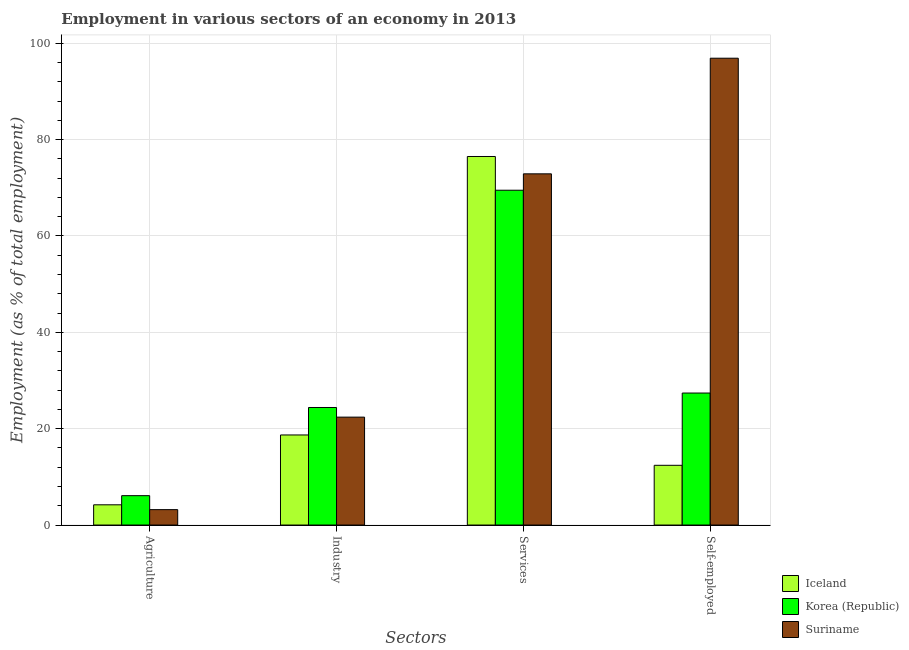How many different coloured bars are there?
Your answer should be compact. 3. Are the number of bars per tick equal to the number of legend labels?
Offer a very short reply. Yes. Are the number of bars on each tick of the X-axis equal?
Offer a terse response. Yes. How many bars are there on the 1st tick from the right?
Your response must be concise. 3. What is the label of the 4th group of bars from the left?
Your answer should be compact. Self-employed. What is the percentage of self employed workers in Suriname?
Offer a terse response. 96.9. Across all countries, what is the maximum percentage of workers in industry?
Your answer should be compact. 24.4. Across all countries, what is the minimum percentage of workers in services?
Your answer should be very brief. 69.5. In which country was the percentage of self employed workers maximum?
Your answer should be very brief. Suriname. In which country was the percentage of workers in services minimum?
Provide a succinct answer. Korea (Republic). What is the total percentage of workers in services in the graph?
Make the answer very short. 218.9. What is the difference between the percentage of workers in agriculture in Iceland and that in Suriname?
Your answer should be compact. 1. What is the difference between the percentage of self employed workers in Iceland and the percentage of workers in services in Suriname?
Your answer should be compact. -60.5. What is the average percentage of workers in agriculture per country?
Your answer should be very brief. 4.5. What is the difference between the percentage of workers in industry and percentage of workers in agriculture in Suriname?
Offer a terse response. 19.2. What is the ratio of the percentage of workers in industry in Iceland to that in Korea (Republic)?
Your answer should be very brief. 0.77. Is the percentage of workers in services in Korea (Republic) less than that in Suriname?
Offer a terse response. Yes. Is the difference between the percentage of self employed workers in Korea (Republic) and Suriname greater than the difference between the percentage of workers in services in Korea (Republic) and Suriname?
Provide a short and direct response. No. What is the difference between the highest and the second highest percentage of workers in agriculture?
Your answer should be very brief. 1.9. What is the difference between the highest and the lowest percentage of workers in services?
Give a very brief answer. 7. In how many countries, is the percentage of workers in agriculture greater than the average percentage of workers in agriculture taken over all countries?
Your answer should be very brief. 1. Is it the case that in every country, the sum of the percentage of workers in industry and percentage of workers in services is greater than the sum of percentage of self employed workers and percentage of workers in agriculture?
Your response must be concise. No. What does the 3rd bar from the right in Agriculture represents?
Your answer should be very brief. Iceland. Is it the case that in every country, the sum of the percentage of workers in agriculture and percentage of workers in industry is greater than the percentage of workers in services?
Offer a terse response. No. Where does the legend appear in the graph?
Offer a terse response. Bottom right. How many legend labels are there?
Your answer should be compact. 3. What is the title of the graph?
Offer a very short reply. Employment in various sectors of an economy in 2013. Does "Sint Maarten (Dutch part)" appear as one of the legend labels in the graph?
Keep it short and to the point. No. What is the label or title of the X-axis?
Offer a terse response. Sectors. What is the label or title of the Y-axis?
Make the answer very short. Employment (as % of total employment). What is the Employment (as % of total employment) in Iceland in Agriculture?
Offer a terse response. 4.2. What is the Employment (as % of total employment) in Korea (Republic) in Agriculture?
Provide a short and direct response. 6.1. What is the Employment (as % of total employment) in Suriname in Agriculture?
Keep it short and to the point. 3.2. What is the Employment (as % of total employment) in Iceland in Industry?
Ensure brevity in your answer.  18.7. What is the Employment (as % of total employment) in Korea (Republic) in Industry?
Ensure brevity in your answer.  24.4. What is the Employment (as % of total employment) in Suriname in Industry?
Offer a very short reply. 22.4. What is the Employment (as % of total employment) of Iceland in Services?
Offer a terse response. 76.5. What is the Employment (as % of total employment) in Korea (Republic) in Services?
Your answer should be very brief. 69.5. What is the Employment (as % of total employment) of Suriname in Services?
Make the answer very short. 72.9. What is the Employment (as % of total employment) in Iceland in Self-employed?
Offer a very short reply. 12.4. What is the Employment (as % of total employment) in Korea (Republic) in Self-employed?
Offer a terse response. 27.4. What is the Employment (as % of total employment) of Suriname in Self-employed?
Give a very brief answer. 96.9. Across all Sectors, what is the maximum Employment (as % of total employment) in Iceland?
Your response must be concise. 76.5. Across all Sectors, what is the maximum Employment (as % of total employment) of Korea (Republic)?
Provide a succinct answer. 69.5. Across all Sectors, what is the maximum Employment (as % of total employment) of Suriname?
Keep it short and to the point. 96.9. Across all Sectors, what is the minimum Employment (as % of total employment) of Iceland?
Ensure brevity in your answer.  4.2. Across all Sectors, what is the minimum Employment (as % of total employment) in Korea (Republic)?
Offer a very short reply. 6.1. Across all Sectors, what is the minimum Employment (as % of total employment) of Suriname?
Make the answer very short. 3.2. What is the total Employment (as % of total employment) of Iceland in the graph?
Your answer should be compact. 111.8. What is the total Employment (as % of total employment) in Korea (Republic) in the graph?
Make the answer very short. 127.4. What is the total Employment (as % of total employment) in Suriname in the graph?
Give a very brief answer. 195.4. What is the difference between the Employment (as % of total employment) of Korea (Republic) in Agriculture and that in Industry?
Provide a succinct answer. -18.3. What is the difference between the Employment (as % of total employment) in Suriname in Agriculture and that in Industry?
Give a very brief answer. -19.2. What is the difference between the Employment (as % of total employment) of Iceland in Agriculture and that in Services?
Give a very brief answer. -72.3. What is the difference between the Employment (as % of total employment) of Korea (Republic) in Agriculture and that in Services?
Provide a short and direct response. -63.4. What is the difference between the Employment (as % of total employment) of Suriname in Agriculture and that in Services?
Provide a succinct answer. -69.7. What is the difference between the Employment (as % of total employment) in Iceland in Agriculture and that in Self-employed?
Offer a terse response. -8.2. What is the difference between the Employment (as % of total employment) of Korea (Republic) in Agriculture and that in Self-employed?
Your answer should be compact. -21.3. What is the difference between the Employment (as % of total employment) in Suriname in Agriculture and that in Self-employed?
Offer a terse response. -93.7. What is the difference between the Employment (as % of total employment) in Iceland in Industry and that in Services?
Give a very brief answer. -57.8. What is the difference between the Employment (as % of total employment) in Korea (Republic) in Industry and that in Services?
Offer a very short reply. -45.1. What is the difference between the Employment (as % of total employment) of Suriname in Industry and that in Services?
Your response must be concise. -50.5. What is the difference between the Employment (as % of total employment) of Suriname in Industry and that in Self-employed?
Ensure brevity in your answer.  -74.5. What is the difference between the Employment (as % of total employment) in Iceland in Services and that in Self-employed?
Offer a terse response. 64.1. What is the difference between the Employment (as % of total employment) of Korea (Republic) in Services and that in Self-employed?
Provide a succinct answer. 42.1. What is the difference between the Employment (as % of total employment) of Iceland in Agriculture and the Employment (as % of total employment) of Korea (Republic) in Industry?
Your answer should be compact. -20.2. What is the difference between the Employment (as % of total employment) of Iceland in Agriculture and the Employment (as % of total employment) of Suriname in Industry?
Your answer should be very brief. -18.2. What is the difference between the Employment (as % of total employment) in Korea (Republic) in Agriculture and the Employment (as % of total employment) in Suriname in Industry?
Your answer should be very brief. -16.3. What is the difference between the Employment (as % of total employment) of Iceland in Agriculture and the Employment (as % of total employment) of Korea (Republic) in Services?
Give a very brief answer. -65.3. What is the difference between the Employment (as % of total employment) in Iceland in Agriculture and the Employment (as % of total employment) in Suriname in Services?
Your answer should be compact. -68.7. What is the difference between the Employment (as % of total employment) in Korea (Republic) in Agriculture and the Employment (as % of total employment) in Suriname in Services?
Offer a terse response. -66.8. What is the difference between the Employment (as % of total employment) in Iceland in Agriculture and the Employment (as % of total employment) in Korea (Republic) in Self-employed?
Keep it short and to the point. -23.2. What is the difference between the Employment (as % of total employment) in Iceland in Agriculture and the Employment (as % of total employment) in Suriname in Self-employed?
Keep it short and to the point. -92.7. What is the difference between the Employment (as % of total employment) of Korea (Republic) in Agriculture and the Employment (as % of total employment) of Suriname in Self-employed?
Give a very brief answer. -90.8. What is the difference between the Employment (as % of total employment) in Iceland in Industry and the Employment (as % of total employment) in Korea (Republic) in Services?
Provide a succinct answer. -50.8. What is the difference between the Employment (as % of total employment) in Iceland in Industry and the Employment (as % of total employment) in Suriname in Services?
Provide a succinct answer. -54.2. What is the difference between the Employment (as % of total employment) of Korea (Republic) in Industry and the Employment (as % of total employment) of Suriname in Services?
Your answer should be very brief. -48.5. What is the difference between the Employment (as % of total employment) in Iceland in Industry and the Employment (as % of total employment) in Suriname in Self-employed?
Provide a short and direct response. -78.2. What is the difference between the Employment (as % of total employment) in Korea (Republic) in Industry and the Employment (as % of total employment) in Suriname in Self-employed?
Provide a succinct answer. -72.5. What is the difference between the Employment (as % of total employment) in Iceland in Services and the Employment (as % of total employment) in Korea (Republic) in Self-employed?
Make the answer very short. 49.1. What is the difference between the Employment (as % of total employment) of Iceland in Services and the Employment (as % of total employment) of Suriname in Self-employed?
Keep it short and to the point. -20.4. What is the difference between the Employment (as % of total employment) of Korea (Republic) in Services and the Employment (as % of total employment) of Suriname in Self-employed?
Keep it short and to the point. -27.4. What is the average Employment (as % of total employment) in Iceland per Sectors?
Offer a very short reply. 27.95. What is the average Employment (as % of total employment) of Korea (Republic) per Sectors?
Your answer should be very brief. 31.85. What is the average Employment (as % of total employment) of Suriname per Sectors?
Your answer should be very brief. 48.85. What is the difference between the Employment (as % of total employment) of Iceland and Employment (as % of total employment) of Korea (Republic) in Agriculture?
Offer a terse response. -1.9. What is the difference between the Employment (as % of total employment) in Iceland and Employment (as % of total employment) in Suriname in Agriculture?
Ensure brevity in your answer.  1. What is the difference between the Employment (as % of total employment) of Korea (Republic) and Employment (as % of total employment) of Suriname in Agriculture?
Ensure brevity in your answer.  2.9. What is the difference between the Employment (as % of total employment) in Iceland and Employment (as % of total employment) in Korea (Republic) in Industry?
Keep it short and to the point. -5.7. What is the difference between the Employment (as % of total employment) of Korea (Republic) and Employment (as % of total employment) of Suriname in Industry?
Provide a short and direct response. 2. What is the difference between the Employment (as % of total employment) of Iceland and Employment (as % of total employment) of Korea (Republic) in Services?
Your answer should be very brief. 7. What is the difference between the Employment (as % of total employment) in Iceland and Employment (as % of total employment) in Korea (Republic) in Self-employed?
Your response must be concise. -15. What is the difference between the Employment (as % of total employment) in Iceland and Employment (as % of total employment) in Suriname in Self-employed?
Offer a terse response. -84.5. What is the difference between the Employment (as % of total employment) of Korea (Republic) and Employment (as % of total employment) of Suriname in Self-employed?
Make the answer very short. -69.5. What is the ratio of the Employment (as % of total employment) of Iceland in Agriculture to that in Industry?
Make the answer very short. 0.22. What is the ratio of the Employment (as % of total employment) in Suriname in Agriculture to that in Industry?
Your answer should be very brief. 0.14. What is the ratio of the Employment (as % of total employment) in Iceland in Agriculture to that in Services?
Your answer should be compact. 0.05. What is the ratio of the Employment (as % of total employment) of Korea (Republic) in Agriculture to that in Services?
Provide a short and direct response. 0.09. What is the ratio of the Employment (as % of total employment) in Suriname in Agriculture to that in Services?
Provide a short and direct response. 0.04. What is the ratio of the Employment (as % of total employment) in Iceland in Agriculture to that in Self-employed?
Ensure brevity in your answer.  0.34. What is the ratio of the Employment (as % of total employment) of Korea (Republic) in Agriculture to that in Self-employed?
Provide a short and direct response. 0.22. What is the ratio of the Employment (as % of total employment) in Suriname in Agriculture to that in Self-employed?
Offer a very short reply. 0.03. What is the ratio of the Employment (as % of total employment) of Iceland in Industry to that in Services?
Provide a succinct answer. 0.24. What is the ratio of the Employment (as % of total employment) of Korea (Republic) in Industry to that in Services?
Provide a short and direct response. 0.35. What is the ratio of the Employment (as % of total employment) in Suriname in Industry to that in Services?
Ensure brevity in your answer.  0.31. What is the ratio of the Employment (as % of total employment) of Iceland in Industry to that in Self-employed?
Your answer should be very brief. 1.51. What is the ratio of the Employment (as % of total employment) in Korea (Republic) in Industry to that in Self-employed?
Provide a succinct answer. 0.89. What is the ratio of the Employment (as % of total employment) in Suriname in Industry to that in Self-employed?
Offer a terse response. 0.23. What is the ratio of the Employment (as % of total employment) in Iceland in Services to that in Self-employed?
Keep it short and to the point. 6.17. What is the ratio of the Employment (as % of total employment) in Korea (Republic) in Services to that in Self-employed?
Your answer should be compact. 2.54. What is the ratio of the Employment (as % of total employment) of Suriname in Services to that in Self-employed?
Ensure brevity in your answer.  0.75. What is the difference between the highest and the second highest Employment (as % of total employment) of Iceland?
Provide a short and direct response. 57.8. What is the difference between the highest and the second highest Employment (as % of total employment) in Korea (Republic)?
Keep it short and to the point. 42.1. What is the difference between the highest and the lowest Employment (as % of total employment) of Iceland?
Offer a very short reply. 72.3. What is the difference between the highest and the lowest Employment (as % of total employment) in Korea (Republic)?
Provide a succinct answer. 63.4. What is the difference between the highest and the lowest Employment (as % of total employment) in Suriname?
Keep it short and to the point. 93.7. 